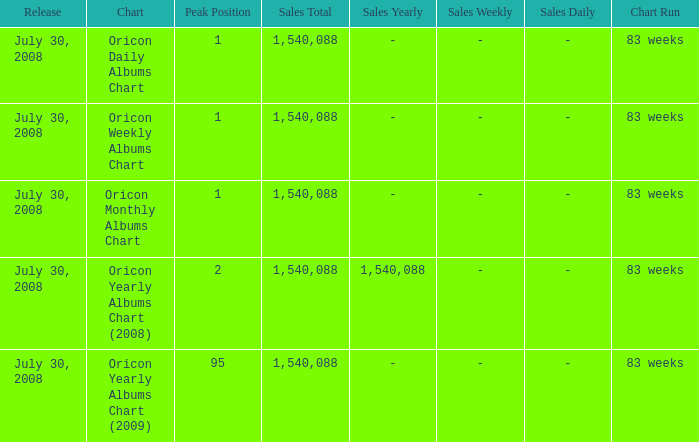Which Sales Total has a Chart of oricon monthly albums chart? 1540088.0. 